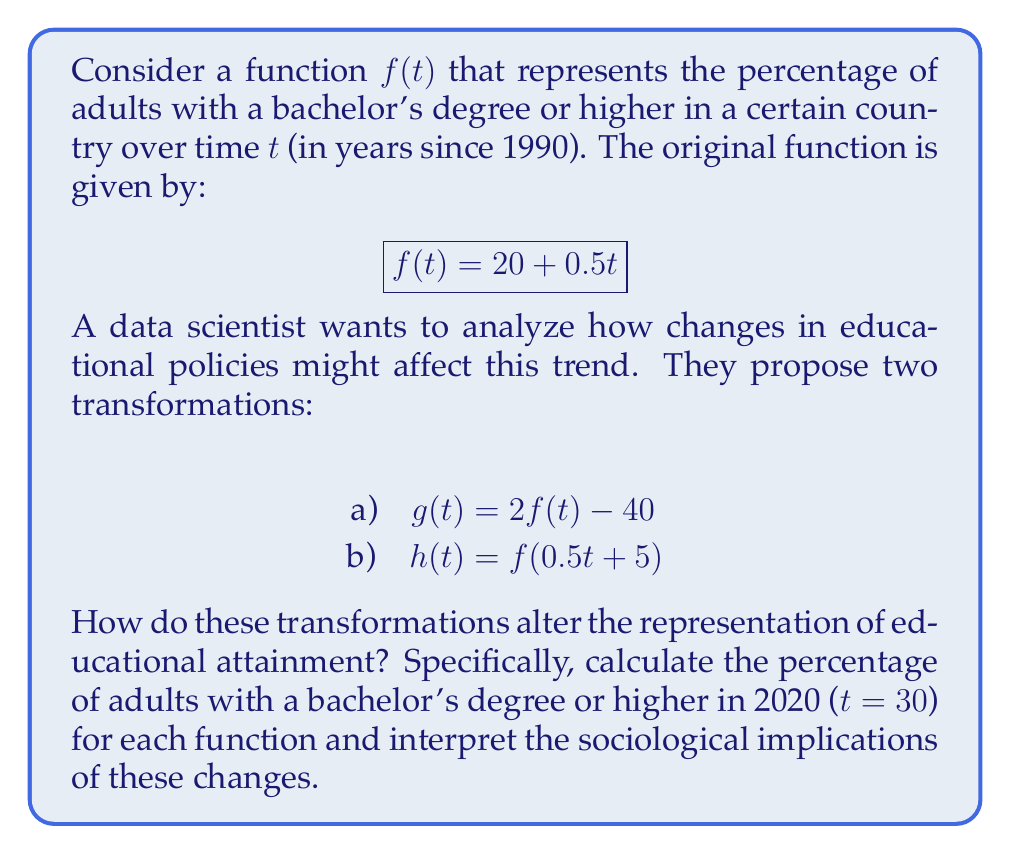Can you answer this question? Let's approach this step-by-step:

1) First, let's calculate the original percentage for 2020 using $f(t)$:
   $$f(30) = 20 + 0.5(30) = 20 + 15 = 35\%$$

2) Now, let's examine transformation a) $g(t) = 2f(t) - 40$:
   $$g(30) = 2f(30) - 40 = 2(35) - 40 = 70 - 40 = 30\%$$

3) For transformation b) $h(t) = f(0.5t + 5)$, we need to calculate:
   $$h(30) = f(0.5(30) + 5) = f(20)$$
   $$f(20) = 20 + 0.5(20) = 20 + 10 = 30\%$$

4) Interpretation:
   - The original function $f(t)$ shows a steady increase, reaching 35% by 2020.
   - Transformation $g(t)$ doubles the rate of increase but subtracts a constant, resulting in 30% by 2020. This could represent a policy that accelerates education but faces initial setbacks.
   - Transformation $h(t)$ compresses the time scale and shifts it, also resulting in 30% by 2020. This might represent a delayed but accelerated educational program.

5) Sociological implications:
   - The original trend suggests gradual improvement in educational attainment.
   - Transformation $g(t)$ might indicate a more aggressive educational policy with initial challenges, possibly due to resistance or implementation issues.
   - Transformation $h(t)$ could represent a delayed start to a new educational initiative, perhaps due to political or economic factors, but with faster progress once implemented.

These transformations demonstrate how different policy approaches can lead to varied outcomes in educational attainment, reflecting the complex interplay between policy, implementation, and societal factors.
Answer: Original: 35%, Transformed g(t): 30%, Transformed h(t): 30%. Implications: varied policy impacts on educational attainment. 